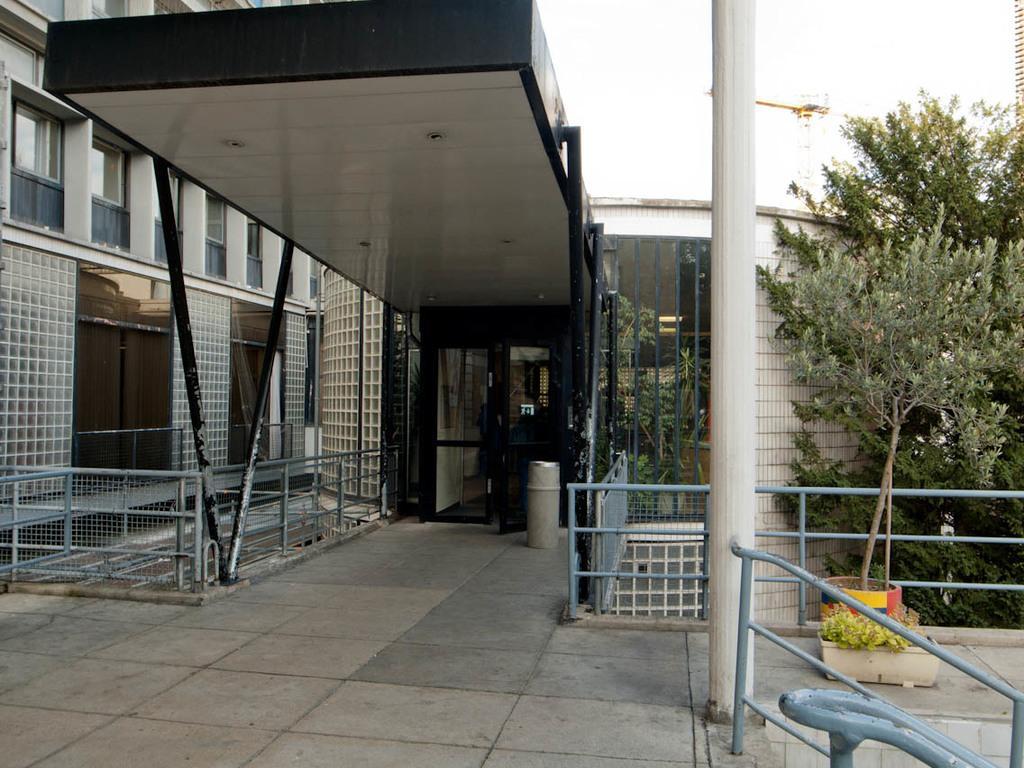Describe this image in one or two sentences. In this image there is a building and pillars. On the right side of the image there are trees, a plant pot and there is a railing. 